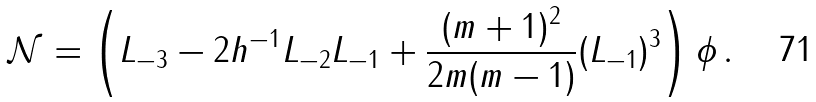Convert formula to latex. <formula><loc_0><loc_0><loc_500><loc_500>\mathcal { N } = \left ( L _ { - 3 } - 2 h ^ { - 1 } L _ { - 2 } L _ { - 1 } + \frac { ( m + 1 ) ^ { 2 } } { 2 m ( m - 1 ) } ( L _ { - 1 } ) ^ { 3 } \right ) \phi \, .</formula> 